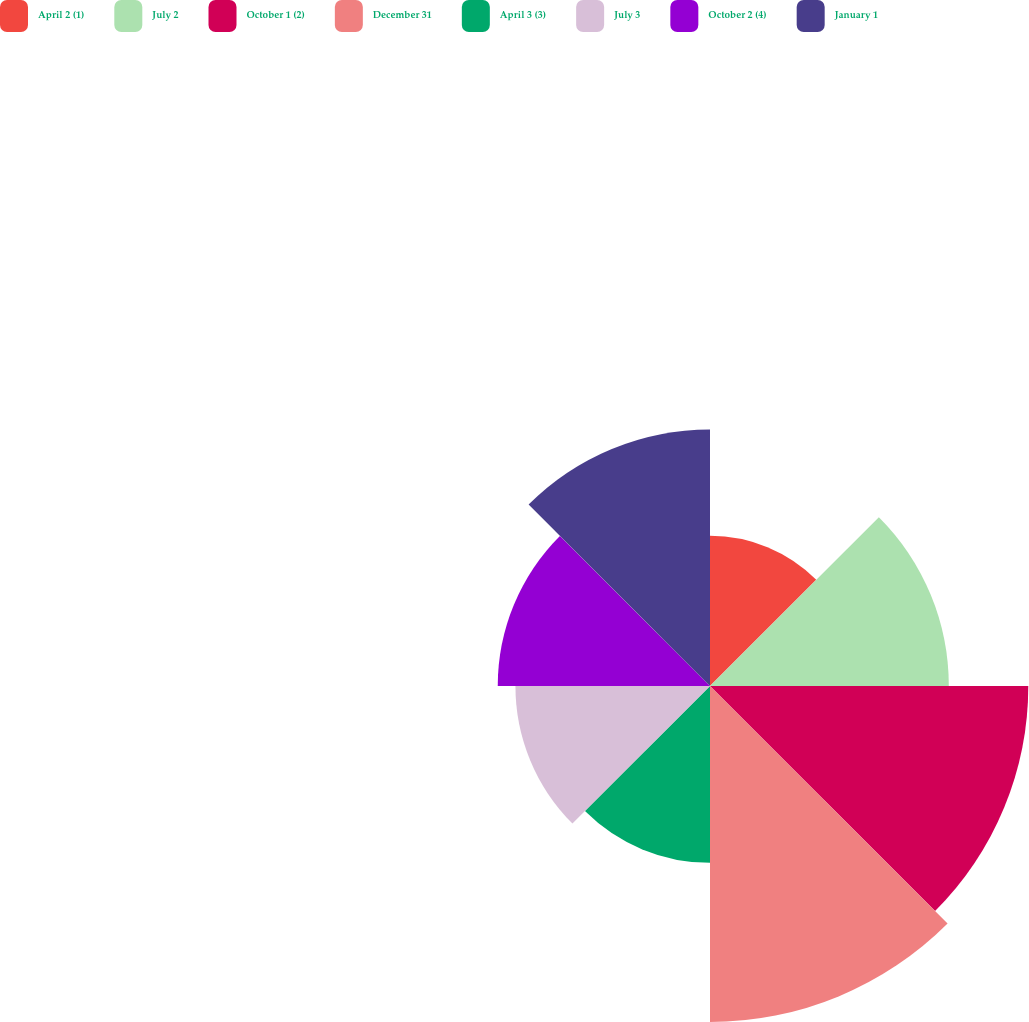<chart> <loc_0><loc_0><loc_500><loc_500><pie_chart><fcel>April 2 (1)<fcel>July 2<fcel>October 1 (2)<fcel>December 31<fcel>April 3 (3)<fcel>July 3<fcel>October 2 (4)<fcel>January 1<nl><fcel>7.98%<fcel>12.68%<fcel>16.9%<fcel>17.84%<fcel>9.39%<fcel>10.33%<fcel>11.27%<fcel>13.62%<nl></chart> 